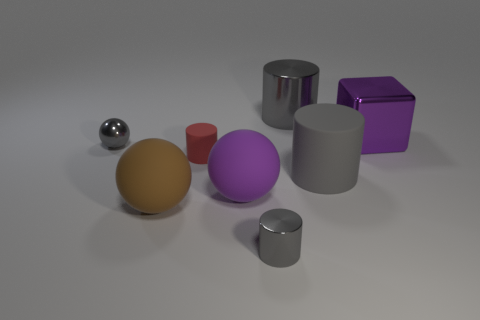Subtract all gray cylinders. How many were subtracted if there are2gray cylinders left? 1 Subtract all gray cylinders. How many cylinders are left? 1 Subtract all brown balls. How many balls are left? 2 Subtract all balls. How many objects are left? 5 Subtract 1 cylinders. How many cylinders are left? 3 Add 5 tiny yellow shiny cubes. How many tiny yellow shiny cubes exist? 5 Add 1 tiny cyan matte cylinders. How many objects exist? 9 Subtract 0 gray blocks. How many objects are left? 8 Subtract all cyan cylinders. Subtract all yellow cubes. How many cylinders are left? 4 Subtract all purple blocks. How many purple spheres are left? 1 